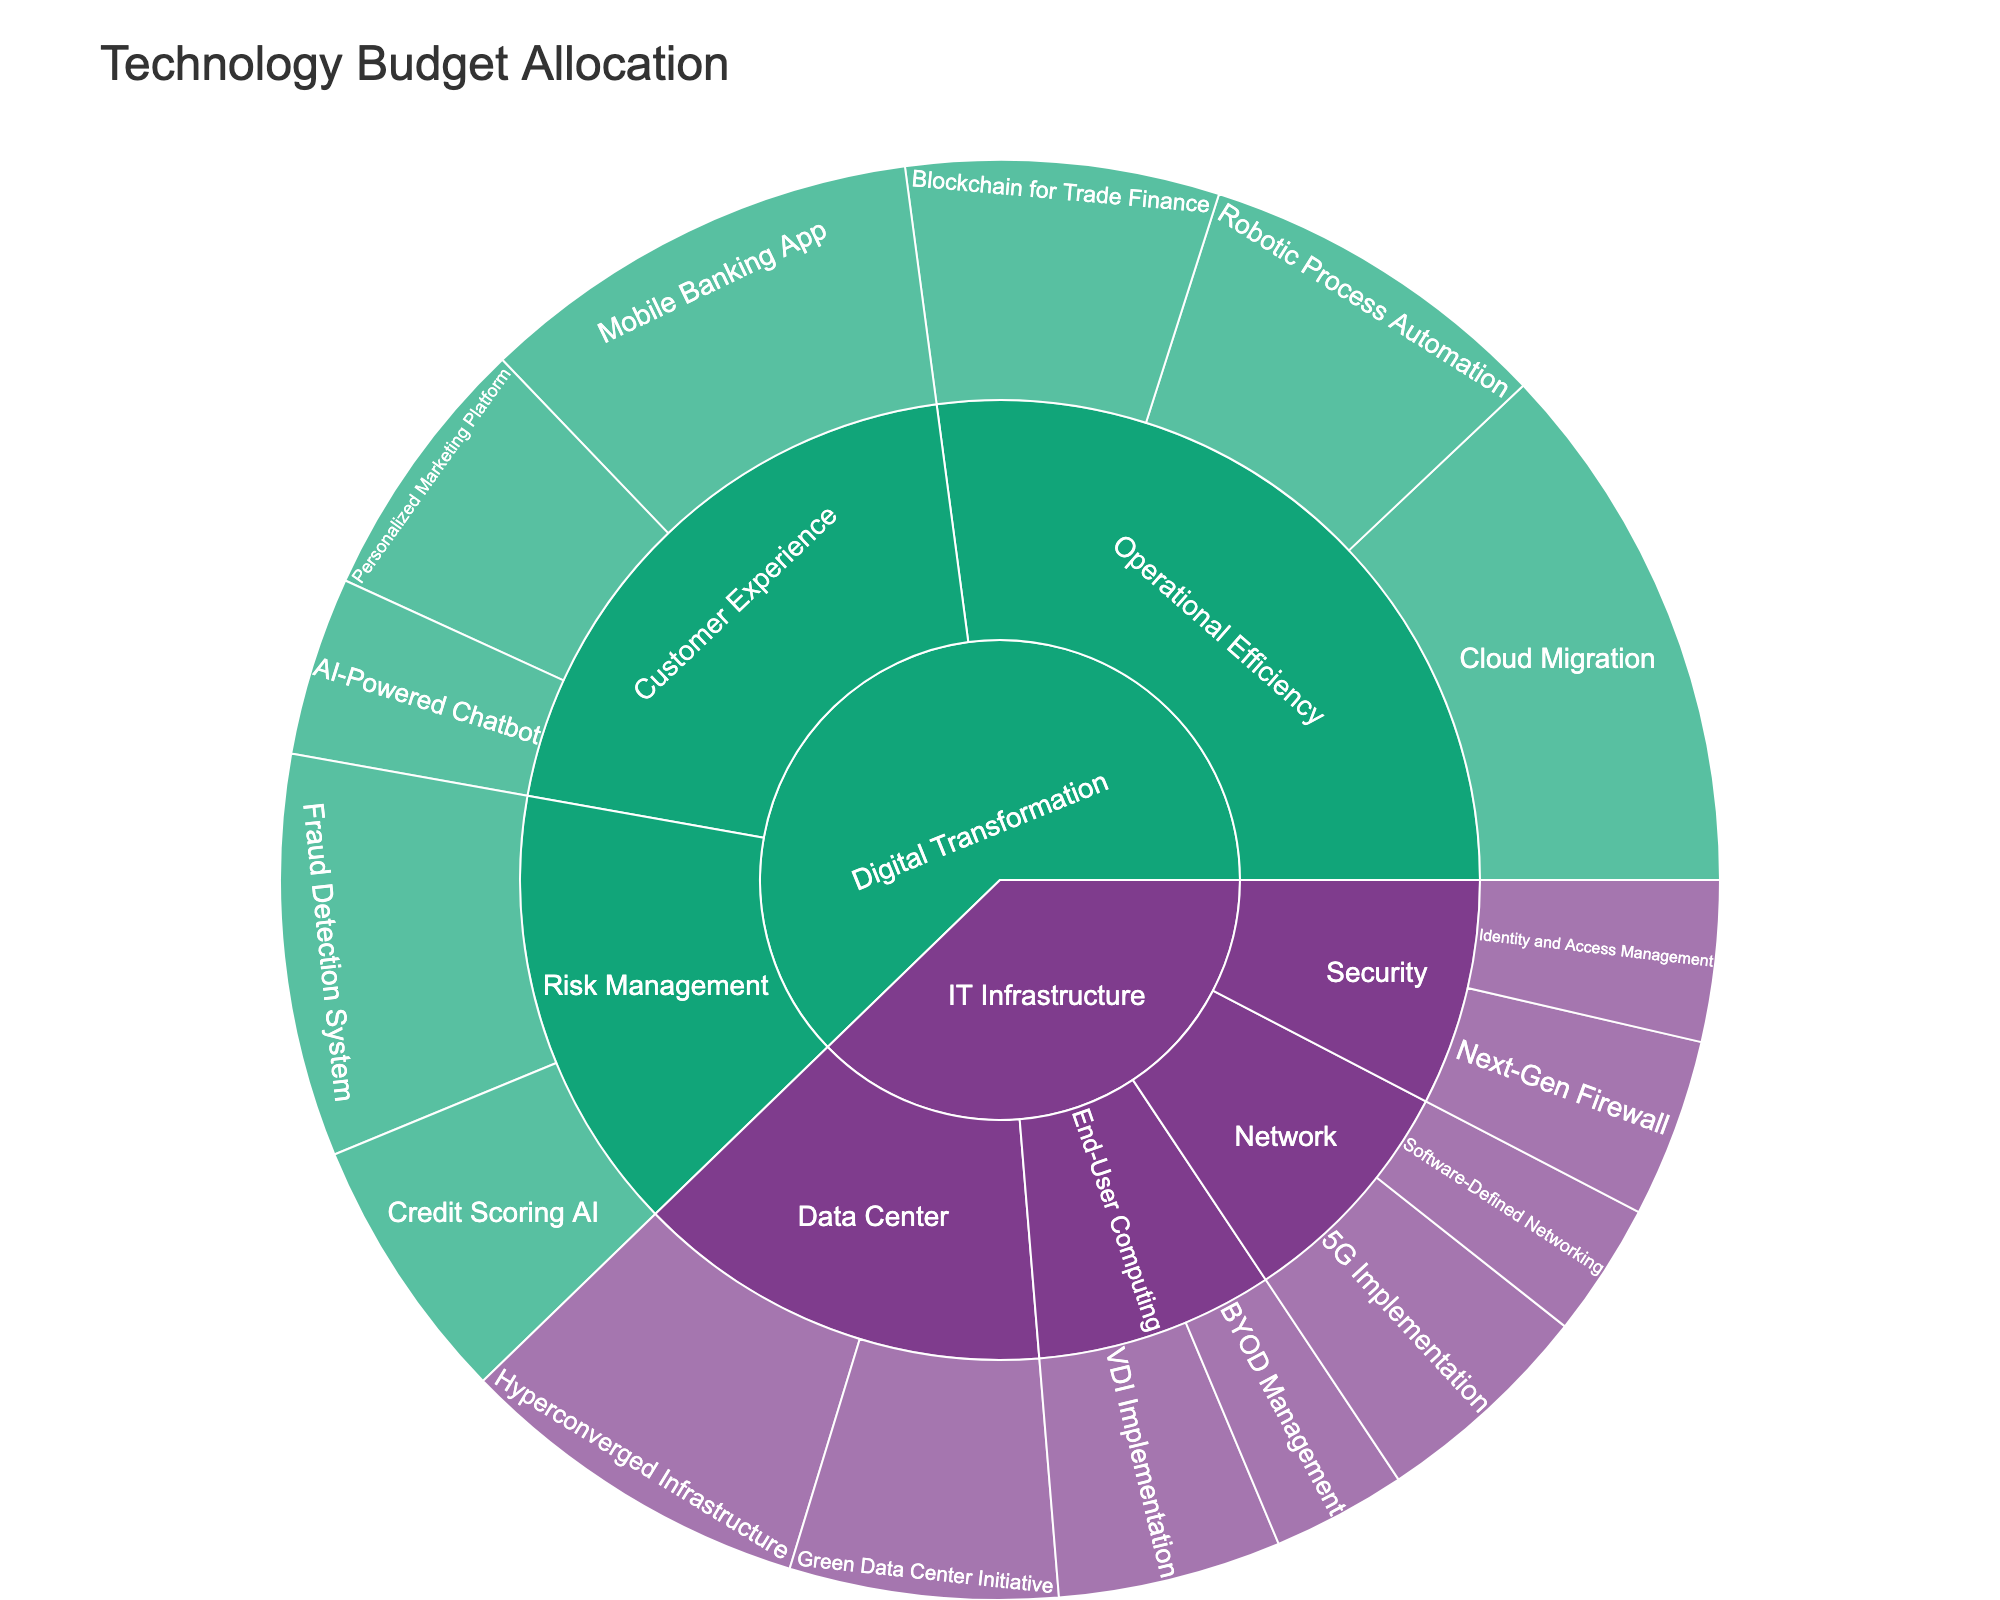What is the total budget allocated to Digital Transformation initiatives? To find the total budget for Digital Transformation, sum up all the budgets of the initiatives under this category: $5,000,000 (Mobile Banking App) + $2,000,000 (AI-Powered Chatbot) + $3,000,000 (Personalized Marketing Platform) + $4,000,000 (Robotic Process Automation) + $3,500,000 (Blockchain for Trade Finance) + $6,000,000 (Cloud Migration) + $4,500,000 (Fraud Detection System) + $3,000,000 (Credit Scoring AI) = $31,000,000
Answer: $31,000,000 What is the budget for the Mobile Banking App compared to the Robotic Process Automation initiative? The budget for Mobile Banking App is $5,000,000, and for Robotic Process Automation is $4,000,000. Comparing the two, Mobile Banking App has a higher budget than Robotic Process Automation.
Answer: Mobile Banking App has a higher budget Which subcategory within Digital Transformation has the highest total budget allocation? Summing up the budgets for each subcategory: Customer Experience ($5,000,000 + $2,000,000 + $3,000,000 = $10,000,000), Operational Efficiency ($4,000,000 + $3,500,000 + $6,000,000 = $13,500,000), and Risk Management ($4,500,000 + $3,000,000 = $7,500,000). Operational Efficiency has the highest total budget.
Answer: Operational Efficiency What is the difference in budget allocation between the highest and lowest funded initiatives in IT Infrastructure? The highest funded initiative in IT Infrastructure is Hyperconverged Infrastructure with $4,000,000, and the lowest funded are Software-Defined Networking and BYOD Management each with $1,500,000. The difference is $4,000,000 - $1,500,000 = $2,500,000.
Answer: $2,500,000 How does the total budget for Risk Management in Digital Transformation compare to the total budget for Security in IT Infrastructure? Total budget for Risk Management is $4,500,000 (Fraud Detection System) + $3,000,000 (Credit Scoring AI) = $7,500,000. Total budget for Security is $2,000,000 (Next-Gen Firewall) + $1,800,000 (Identity and Access Management) = $3,800,000. Risk Management has a higher budget.
Answer: Risk Management has a higher budget What percentage of the total budget for IT Infrastructure is allocated to Data Center initiatives? The total budget for IT Infrastructure is $2,500,000 (5G Implementation) + $1,500,000 (Software-Defined Networking) + $2,000,000 (Next-Gen Firewall) + $1,800,000 (Identity and Access Management) + $4,000,000 (Hyperconverged Infrastructure) + $3,000,000 (Green Data Center Initiative) + $2,500,000 (VDI Implementation) + $1,500,000 (BYOD Management) = $18,800,000. The budget for Data Center is $4,000,000 (Hyperconverged Infrastructure) + $3,000,000 (Green Data Center Initiative) = $7,000,000. The percentage is ($7,000,000 / $18,800,000) * 100 ≈ 37.23%.
Answer: 37.23% What initiative under Customer Experience has the lowest budget allocation? Under Customer Experience, the initiatives and their budgets are Mobile Banking App ($5,000,000), AI-Powered Chatbot ($2,000,000), and Personalized Marketing Platform ($3,000,000). The AI-Powered Chatbot has the lowest budget allocation.
Answer: AI-Powered Chatbot How does the budget for Cloud Migration compare to the budget for Hyperconverged Infrastructure? Cloud Migration has a budget of $6,000,000, while Hyperconverged Infrastructure has a budget of $4,000,000. Cloud Migration has a higher budget.
Answer: Cloud Migration has a higher budget Which has a larger budget allocation: End-User Computing in IT Infrastructure or Customer Experience in Digital Transformation? The total budget for End-User Computing is $2,500,000 (VDI Implementation) + $1,500,000 (BYOD Management) = $4,000,000. The total budget for Customer Experience is $5,000,000 (Mobile Banking App) + $2,000,000 (AI-Powered Chatbot) + $3,000,000 (Personalized Marketing Platform) = $10,000,000. Customer Experience has a larger budget allocation.
Answer: Customer Experience 